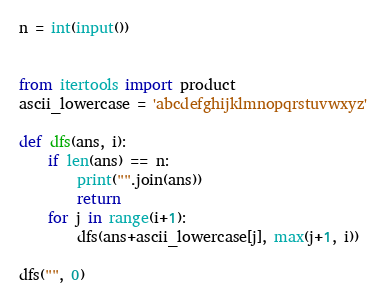Convert code to text. <code><loc_0><loc_0><loc_500><loc_500><_Python_>n = int(input())


from itertools import product
ascii_lowercase = 'abcdefghijklmnopqrstuvwxyz'

def dfs(ans, i):
    if len(ans) == n:
        print("".join(ans))
        return
    for j in range(i+1):
        dfs(ans+ascii_lowercase[j], max(j+1, i))

dfs("", 0)</code> 